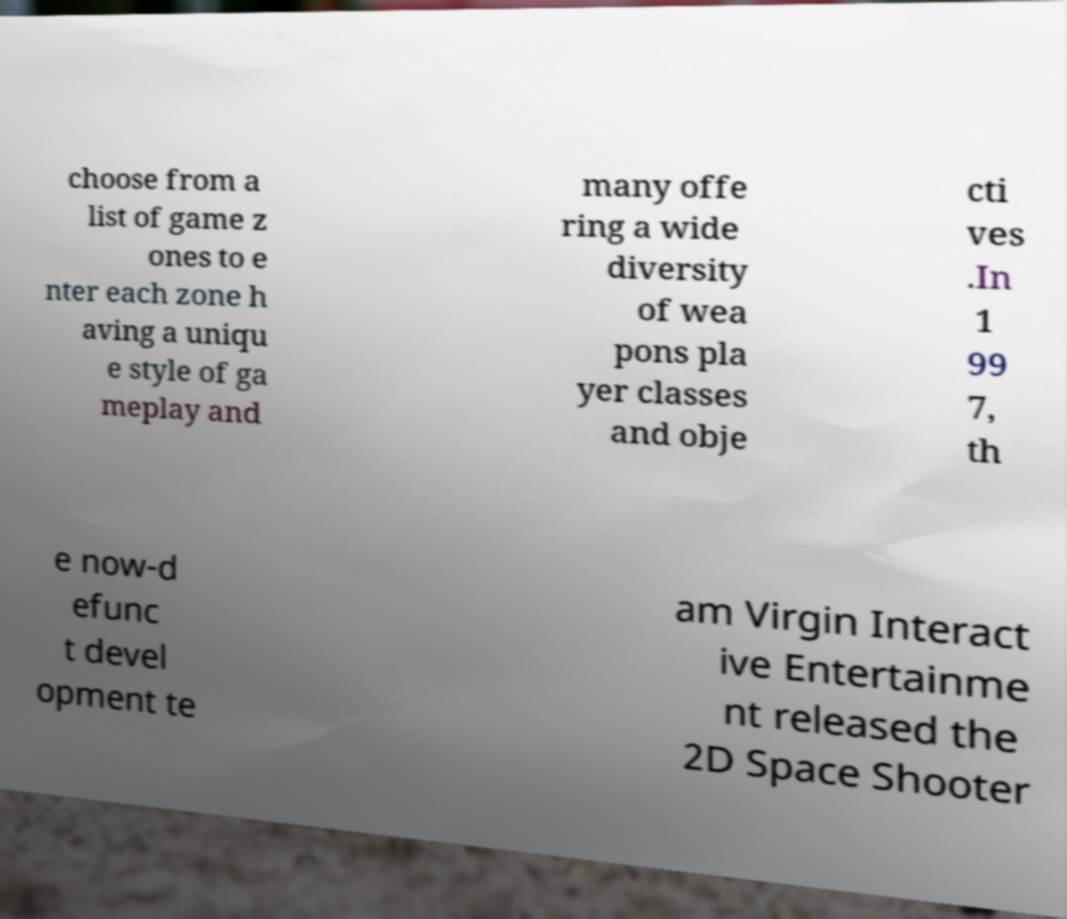Please read and relay the text visible in this image. What does it say? choose from a list of game z ones to e nter each zone h aving a uniqu e style of ga meplay and many offe ring a wide diversity of wea pons pla yer classes and obje cti ves .In 1 99 7, th e now-d efunc t devel opment te am Virgin Interact ive Entertainme nt released the 2D Space Shooter 